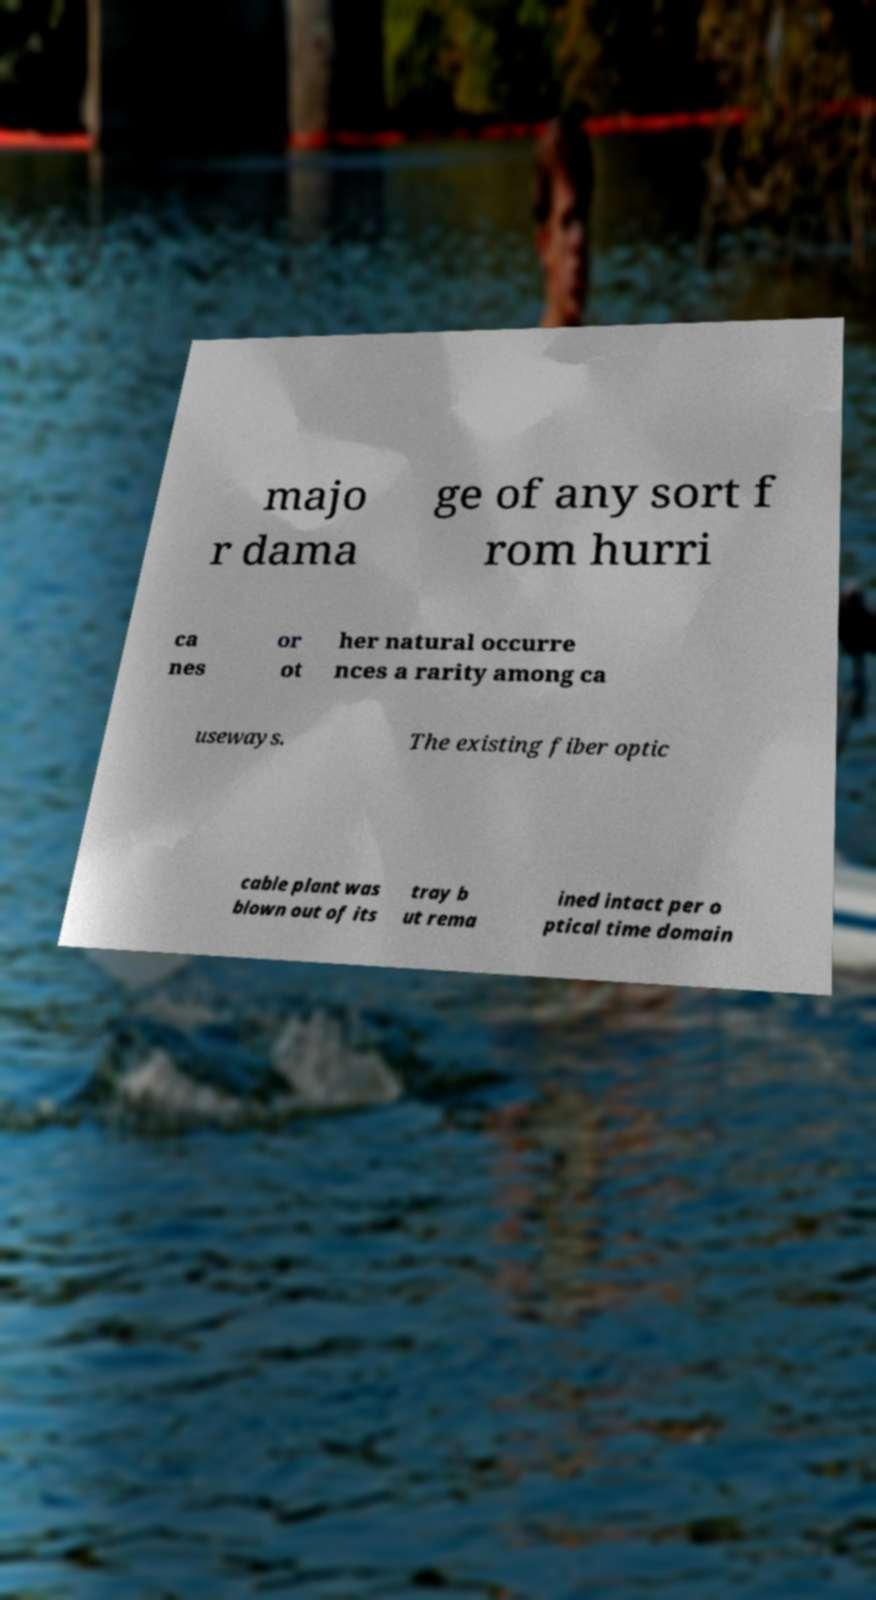Please read and relay the text visible in this image. What does it say? majo r dama ge of any sort f rom hurri ca nes or ot her natural occurre nces a rarity among ca useways. The existing fiber optic cable plant was blown out of its tray b ut rema ined intact per o ptical time domain 